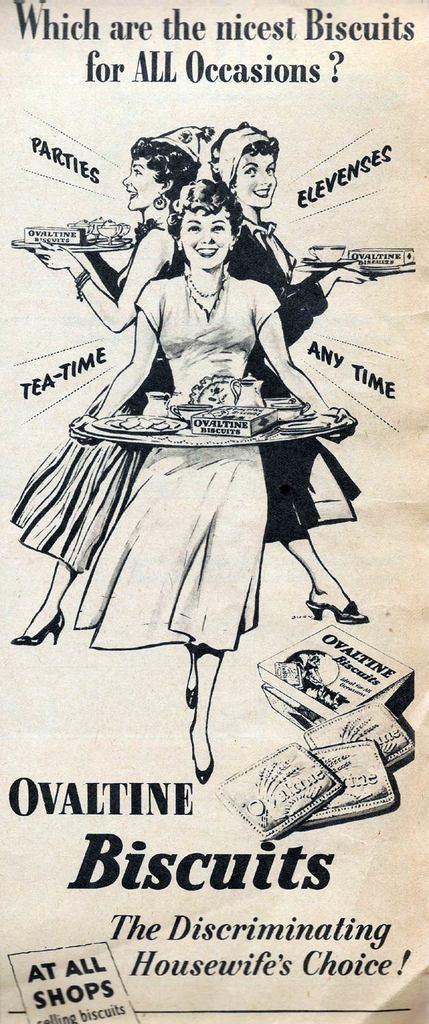In one or two sentences, can you explain what this image depicts? In the picture we can see a magazine paper with an image of three women standing and holding a plate with food items in it and under it we can see an advertisement of biscuits. 